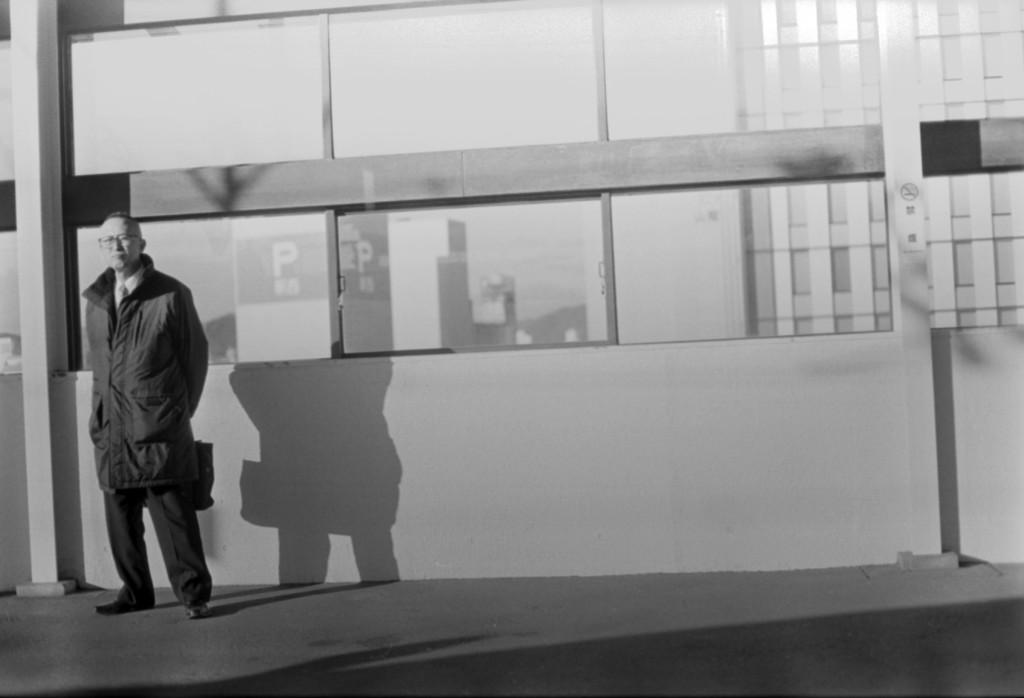What is the color scheme of the image? The image is black and white. Where is the person located in the image? The person is standing on the left side of the image. What is the person holding in the image? The person is holding an object. What can be seen in the background of the image? There is a building in the background of the image. What type of account does the person have in the image? There is no indication of an account in the image, as it is a black and white image of a person standing and holding an object with a building in the background. 